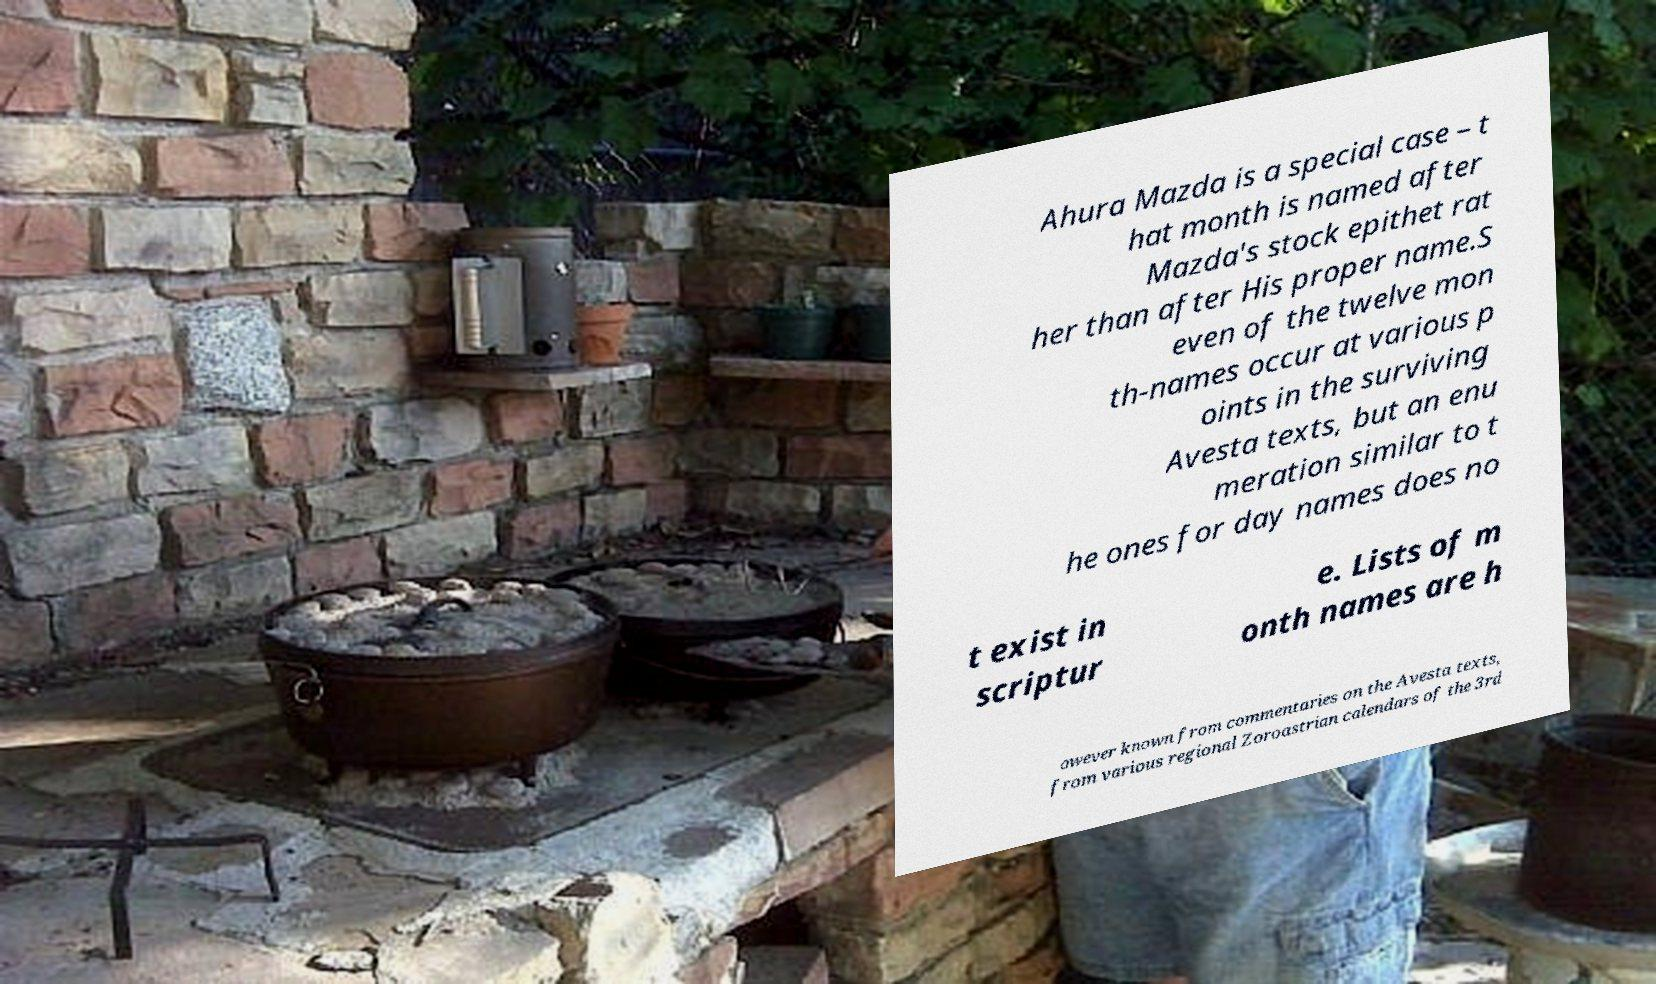There's text embedded in this image that I need extracted. Can you transcribe it verbatim? Ahura Mazda is a special case – t hat month is named after Mazda's stock epithet rat her than after His proper name.S even of the twelve mon th-names occur at various p oints in the surviving Avesta texts, but an enu meration similar to t he ones for day names does no t exist in scriptur e. Lists of m onth names are h owever known from commentaries on the Avesta texts, from various regional Zoroastrian calendars of the 3rd 